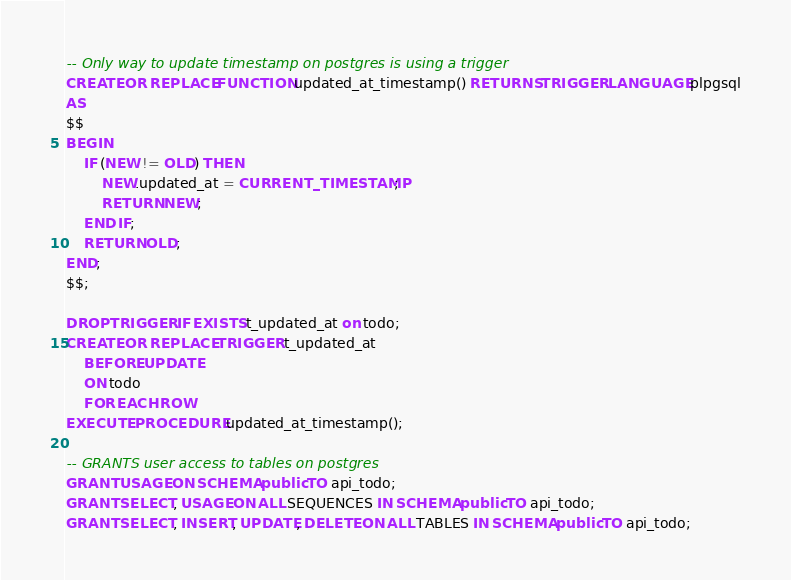<code> <loc_0><loc_0><loc_500><loc_500><_SQL_>-- Only way to update timestamp on postgres is using a trigger
CREATE OR REPLACE FUNCTION updated_at_timestamp() RETURNS TRIGGER LANGUAGE plpgsql
AS
$$
BEGIN
    IF (NEW != OLD) THEN
        NEW.updated_at = CURRENT_TIMESTAMP;
        RETURN NEW;
    END IF;
    RETURN OLD;
END;
$$;

DROP TRIGGER IF EXISTS t_updated_at on todo;
CREATE OR REPLACE TRIGGER t_updated_at
    BEFORE UPDATE
    ON todo
    FOR EACH ROW
EXECUTE PROCEDURE updated_at_timestamp();

-- GRANTS user access to tables on postgres
GRANT USAGE ON SCHEMA public TO api_todo;
GRANT SELECT, USAGE ON ALL SEQUENCES IN SCHEMA public TO api_todo;
GRANT SELECT, INSERT, UPDATE, DELETE ON ALL TABLES IN SCHEMA public TO api_todo;</code> 